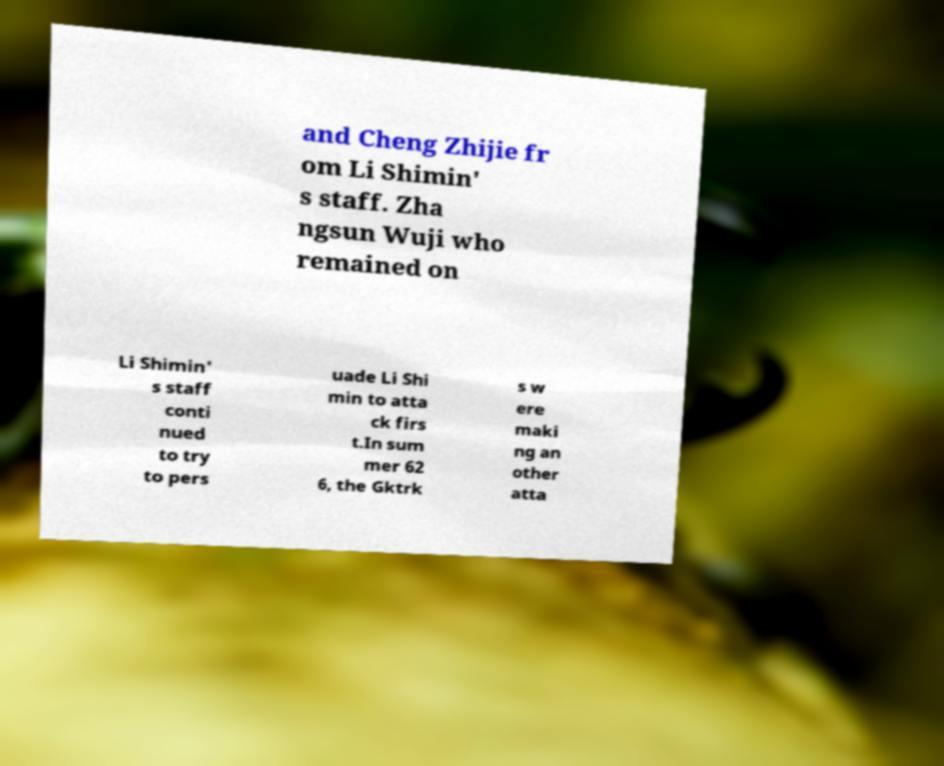Please identify and transcribe the text found in this image. and Cheng Zhijie fr om Li Shimin' s staff. Zha ngsun Wuji who remained on Li Shimin' s staff conti nued to try to pers uade Li Shi min to atta ck firs t.In sum mer 62 6, the Gktrk s w ere maki ng an other atta 